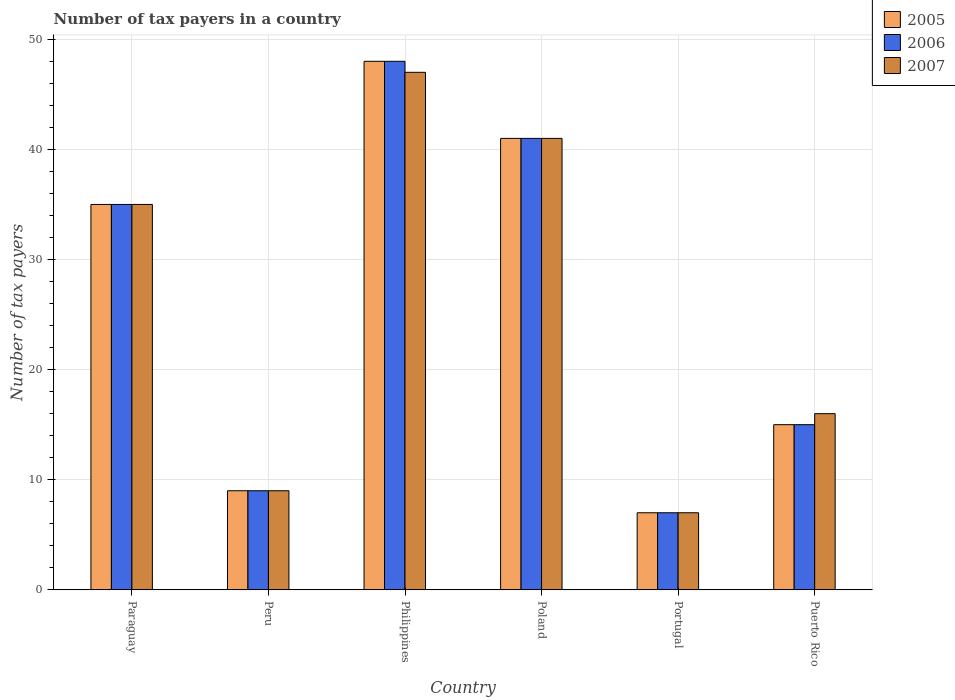How many bars are there on the 3rd tick from the left?
Make the answer very short. 3. What is the label of the 2nd group of bars from the left?
Provide a short and direct response. Peru. In how many cases, is the number of bars for a given country not equal to the number of legend labels?
Provide a short and direct response. 0. Across all countries, what is the minimum number of tax payers in in 2005?
Make the answer very short. 7. In which country was the number of tax payers in in 2006 maximum?
Provide a short and direct response. Philippines. In which country was the number of tax payers in in 2007 minimum?
Keep it short and to the point. Portugal. What is the total number of tax payers in in 2006 in the graph?
Provide a succinct answer. 155. What is the difference between the number of tax payers in in 2005 in Poland and that in Puerto Rico?
Provide a succinct answer. 26. What is the average number of tax payers in in 2005 per country?
Provide a succinct answer. 25.83. In how many countries, is the number of tax payers in in 2007 greater than 6?
Provide a short and direct response. 6. What is the ratio of the number of tax payers in in 2007 in Philippines to that in Puerto Rico?
Give a very brief answer. 2.94. Is the number of tax payers in in 2005 in Philippines less than that in Poland?
Give a very brief answer. No. In how many countries, is the number of tax payers in in 2007 greater than the average number of tax payers in in 2007 taken over all countries?
Your answer should be compact. 3. What does the 3rd bar from the left in Poland represents?
Provide a succinct answer. 2007. Is it the case that in every country, the sum of the number of tax payers in in 2005 and number of tax payers in in 2007 is greater than the number of tax payers in in 2006?
Your response must be concise. Yes. How many bars are there?
Ensure brevity in your answer.  18. How many countries are there in the graph?
Offer a very short reply. 6. What is the difference between two consecutive major ticks on the Y-axis?
Your response must be concise. 10. Where does the legend appear in the graph?
Provide a short and direct response. Top right. How many legend labels are there?
Offer a terse response. 3. What is the title of the graph?
Keep it short and to the point. Number of tax payers in a country. What is the label or title of the X-axis?
Give a very brief answer. Country. What is the label or title of the Y-axis?
Offer a terse response. Number of tax payers. What is the Number of tax payers in 2006 in Peru?
Your answer should be very brief. 9. What is the Number of tax payers of 2005 in Philippines?
Keep it short and to the point. 48. What is the Number of tax payers in 2007 in Philippines?
Offer a terse response. 47. What is the Number of tax payers in 2006 in Poland?
Your response must be concise. 41. What is the Number of tax payers of 2007 in Poland?
Your answer should be compact. 41. What is the Number of tax payers in 2005 in Portugal?
Your response must be concise. 7. What is the Number of tax payers in 2006 in Puerto Rico?
Provide a succinct answer. 15. Across all countries, what is the maximum Number of tax payers in 2007?
Provide a succinct answer. 47. Across all countries, what is the minimum Number of tax payers in 2005?
Offer a terse response. 7. Across all countries, what is the minimum Number of tax payers of 2006?
Provide a succinct answer. 7. Across all countries, what is the minimum Number of tax payers in 2007?
Keep it short and to the point. 7. What is the total Number of tax payers of 2005 in the graph?
Your answer should be compact. 155. What is the total Number of tax payers of 2006 in the graph?
Your answer should be compact. 155. What is the total Number of tax payers in 2007 in the graph?
Your answer should be very brief. 155. What is the difference between the Number of tax payers in 2005 in Paraguay and that in Peru?
Provide a succinct answer. 26. What is the difference between the Number of tax payers of 2006 in Paraguay and that in Peru?
Your response must be concise. 26. What is the difference between the Number of tax payers in 2005 in Paraguay and that in Philippines?
Ensure brevity in your answer.  -13. What is the difference between the Number of tax payers in 2006 in Paraguay and that in Philippines?
Offer a very short reply. -13. What is the difference between the Number of tax payers of 2007 in Paraguay and that in Philippines?
Your answer should be compact. -12. What is the difference between the Number of tax payers in 2005 in Paraguay and that in Poland?
Keep it short and to the point. -6. What is the difference between the Number of tax payers of 2005 in Paraguay and that in Portugal?
Your response must be concise. 28. What is the difference between the Number of tax payers in 2006 in Paraguay and that in Portugal?
Make the answer very short. 28. What is the difference between the Number of tax payers of 2007 in Paraguay and that in Portugal?
Offer a terse response. 28. What is the difference between the Number of tax payers of 2005 in Peru and that in Philippines?
Your response must be concise. -39. What is the difference between the Number of tax payers in 2006 in Peru and that in Philippines?
Provide a succinct answer. -39. What is the difference between the Number of tax payers of 2007 in Peru and that in Philippines?
Provide a short and direct response. -38. What is the difference between the Number of tax payers in 2005 in Peru and that in Poland?
Provide a succinct answer. -32. What is the difference between the Number of tax payers in 2006 in Peru and that in Poland?
Your answer should be very brief. -32. What is the difference between the Number of tax payers in 2007 in Peru and that in Poland?
Give a very brief answer. -32. What is the difference between the Number of tax payers of 2005 in Peru and that in Puerto Rico?
Your answer should be compact. -6. What is the difference between the Number of tax payers of 2005 in Philippines and that in Poland?
Provide a short and direct response. 7. What is the difference between the Number of tax payers in 2005 in Philippines and that in Portugal?
Your response must be concise. 41. What is the difference between the Number of tax payers of 2007 in Philippines and that in Portugal?
Your response must be concise. 40. What is the difference between the Number of tax payers in 2006 in Philippines and that in Puerto Rico?
Keep it short and to the point. 33. What is the difference between the Number of tax payers in 2007 in Philippines and that in Puerto Rico?
Your answer should be very brief. 31. What is the difference between the Number of tax payers in 2007 in Poland and that in Portugal?
Provide a succinct answer. 34. What is the difference between the Number of tax payers of 2006 in Poland and that in Puerto Rico?
Keep it short and to the point. 26. What is the difference between the Number of tax payers in 2007 in Poland and that in Puerto Rico?
Give a very brief answer. 25. What is the difference between the Number of tax payers in 2006 in Portugal and that in Puerto Rico?
Make the answer very short. -8. What is the difference between the Number of tax payers of 2007 in Portugal and that in Puerto Rico?
Give a very brief answer. -9. What is the difference between the Number of tax payers of 2005 in Paraguay and the Number of tax payers of 2006 in Peru?
Offer a terse response. 26. What is the difference between the Number of tax payers in 2006 in Paraguay and the Number of tax payers in 2007 in Peru?
Provide a succinct answer. 26. What is the difference between the Number of tax payers of 2005 in Paraguay and the Number of tax payers of 2007 in Philippines?
Your answer should be very brief. -12. What is the difference between the Number of tax payers in 2006 in Paraguay and the Number of tax payers in 2007 in Philippines?
Give a very brief answer. -12. What is the difference between the Number of tax payers in 2005 in Paraguay and the Number of tax payers in 2006 in Poland?
Keep it short and to the point. -6. What is the difference between the Number of tax payers in 2005 in Paraguay and the Number of tax payers in 2007 in Poland?
Keep it short and to the point. -6. What is the difference between the Number of tax payers of 2006 in Paraguay and the Number of tax payers of 2007 in Poland?
Make the answer very short. -6. What is the difference between the Number of tax payers in 2005 in Peru and the Number of tax payers in 2006 in Philippines?
Your response must be concise. -39. What is the difference between the Number of tax payers in 2005 in Peru and the Number of tax payers in 2007 in Philippines?
Your answer should be very brief. -38. What is the difference between the Number of tax payers of 2006 in Peru and the Number of tax payers of 2007 in Philippines?
Your answer should be very brief. -38. What is the difference between the Number of tax payers in 2005 in Peru and the Number of tax payers in 2006 in Poland?
Keep it short and to the point. -32. What is the difference between the Number of tax payers of 2005 in Peru and the Number of tax payers of 2007 in Poland?
Offer a very short reply. -32. What is the difference between the Number of tax payers in 2006 in Peru and the Number of tax payers in 2007 in Poland?
Keep it short and to the point. -32. What is the difference between the Number of tax payers in 2005 in Peru and the Number of tax payers in 2006 in Portugal?
Your answer should be compact. 2. What is the difference between the Number of tax payers of 2005 in Peru and the Number of tax payers of 2007 in Portugal?
Offer a terse response. 2. What is the difference between the Number of tax payers in 2005 in Philippines and the Number of tax payers in 2006 in Poland?
Provide a short and direct response. 7. What is the difference between the Number of tax payers of 2006 in Philippines and the Number of tax payers of 2007 in Poland?
Provide a short and direct response. 7. What is the difference between the Number of tax payers in 2006 in Philippines and the Number of tax payers in 2007 in Portugal?
Your answer should be compact. 41. What is the difference between the Number of tax payers in 2005 in Philippines and the Number of tax payers in 2007 in Puerto Rico?
Provide a succinct answer. 32. What is the difference between the Number of tax payers in 2005 in Poland and the Number of tax payers in 2006 in Puerto Rico?
Ensure brevity in your answer.  26. What is the difference between the Number of tax payers in 2005 in Poland and the Number of tax payers in 2007 in Puerto Rico?
Provide a succinct answer. 25. What is the difference between the Number of tax payers of 2005 in Portugal and the Number of tax payers of 2006 in Puerto Rico?
Provide a succinct answer. -8. What is the difference between the Number of tax payers of 2005 in Portugal and the Number of tax payers of 2007 in Puerto Rico?
Make the answer very short. -9. What is the difference between the Number of tax payers of 2006 in Portugal and the Number of tax payers of 2007 in Puerto Rico?
Your answer should be very brief. -9. What is the average Number of tax payers of 2005 per country?
Give a very brief answer. 25.83. What is the average Number of tax payers in 2006 per country?
Offer a terse response. 25.83. What is the average Number of tax payers of 2007 per country?
Your response must be concise. 25.83. What is the difference between the Number of tax payers in 2005 and Number of tax payers in 2007 in Paraguay?
Ensure brevity in your answer.  0. What is the difference between the Number of tax payers of 2006 and Number of tax payers of 2007 in Paraguay?
Provide a short and direct response. 0. What is the difference between the Number of tax payers in 2005 and Number of tax payers in 2006 in Peru?
Provide a short and direct response. 0. What is the difference between the Number of tax payers in 2006 and Number of tax payers in 2007 in Peru?
Your answer should be compact. 0. What is the difference between the Number of tax payers in 2005 and Number of tax payers in 2007 in Poland?
Make the answer very short. 0. What is the difference between the Number of tax payers in 2006 and Number of tax payers in 2007 in Poland?
Ensure brevity in your answer.  0. What is the difference between the Number of tax payers of 2005 and Number of tax payers of 2007 in Portugal?
Your answer should be very brief. 0. What is the difference between the Number of tax payers in 2006 and Number of tax payers in 2007 in Portugal?
Keep it short and to the point. 0. What is the difference between the Number of tax payers in 2005 and Number of tax payers in 2006 in Puerto Rico?
Provide a short and direct response. 0. What is the difference between the Number of tax payers of 2005 and Number of tax payers of 2007 in Puerto Rico?
Your answer should be compact. -1. What is the difference between the Number of tax payers of 2006 and Number of tax payers of 2007 in Puerto Rico?
Provide a succinct answer. -1. What is the ratio of the Number of tax payers of 2005 in Paraguay to that in Peru?
Your response must be concise. 3.89. What is the ratio of the Number of tax payers of 2006 in Paraguay to that in Peru?
Your answer should be very brief. 3.89. What is the ratio of the Number of tax payers of 2007 in Paraguay to that in Peru?
Offer a terse response. 3.89. What is the ratio of the Number of tax payers in 2005 in Paraguay to that in Philippines?
Offer a terse response. 0.73. What is the ratio of the Number of tax payers in 2006 in Paraguay to that in Philippines?
Your answer should be very brief. 0.73. What is the ratio of the Number of tax payers in 2007 in Paraguay to that in Philippines?
Make the answer very short. 0.74. What is the ratio of the Number of tax payers of 2005 in Paraguay to that in Poland?
Ensure brevity in your answer.  0.85. What is the ratio of the Number of tax payers of 2006 in Paraguay to that in Poland?
Provide a short and direct response. 0.85. What is the ratio of the Number of tax payers in 2007 in Paraguay to that in Poland?
Provide a succinct answer. 0.85. What is the ratio of the Number of tax payers in 2005 in Paraguay to that in Portugal?
Keep it short and to the point. 5. What is the ratio of the Number of tax payers of 2006 in Paraguay to that in Portugal?
Your answer should be very brief. 5. What is the ratio of the Number of tax payers of 2005 in Paraguay to that in Puerto Rico?
Keep it short and to the point. 2.33. What is the ratio of the Number of tax payers in 2006 in Paraguay to that in Puerto Rico?
Your answer should be very brief. 2.33. What is the ratio of the Number of tax payers in 2007 in Paraguay to that in Puerto Rico?
Your answer should be very brief. 2.19. What is the ratio of the Number of tax payers of 2005 in Peru to that in Philippines?
Keep it short and to the point. 0.19. What is the ratio of the Number of tax payers in 2006 in Peru to that in Philippines?
Provide a succinct answer. 0.19. What is the ratio of the Number of tax payers in 2007 in Peru to that in Philippines?
Your answer should be compact. 0.19. What is the ratio of the Number of tax payers in 2005 in Peru to that in Poland?
Ensure brevity in your answer.  0.22. What is the ratio of the Number of tax payers in 2006 in Peru to that in Poland?
Give a very brief answer. 0.22. What is the ratio of the Number of tax payers of 2007 in Peru to that in Poland?
Your answer should be very brief. 0.22. What is the ratio of the Number of tax payers of 2006 in Peru to that in Portugal?
Provide a succinct answer. 1.29. What is the ratio of the Number of tax payers in 2007 in Peru to that in Portugal?
Make the answer very short. 1.29. What is the ratio of the Number of tax payers of 2006 in Peru to that in Puerto Rico?
Your response must be concise. 0.6. What is the ratio of the Number of tax payers of 2007 in Peru to that in Puerto Rico?
Ensure brevity in your answer.  0.56. What is the ratio of the Number of tax payers in 2005 in Philippines to that in Poland?
Your answer should be very brief. 1.17. What is the ratio of the Number of tax payers in 2006 in Philippines to that in Poland?
Offer a terse response. 1.17. What is the ratio of the Number of tax payers of 2007 in Philippines to that in Poland?
Offer a very short reply. 1.15. What is the ratio of the Number of tax payers in 2005 in Philippines to that in Portugal?
Your answer should be very brief. 6.86. What is the ratio of the Number of tax payers of 2006 in Philippines to that in Portugal?
Your response must be concise. 6.86. What is the ratio of the Number of tax payers of 2007 in Philippines to that in Portugal?
Your answer should be very brief. 6.71. What is the ratio of the Number of tax payers of 2005 in Philippines to that in Puerto Rico?
Make the answer very short. 3.2. What is the ratio of the Number of tax payers in 2007 in Philippines to that in Puerto Rico?
Give a very brief answer. 2.94. What is the ratio of the Number of tax payers of 2005 in Poland to that in Portugal?
Offer a terse response. 5.86. What is the ratio of the Number of tax payers of 2006 in Poland to that in Portugal?
Give a very brief answer. 5.86. What is the ratio of the Number of tax payers of 2007 in Poland to that in Portugal?
Ensure brevity in your answer.  5.86. What is the ratio of the Number of tax payers of 2005 in Poland to that in Puerto Rico?
Provide a succinct answer. 2.73. What is the ratio of the Number of tax payers of 2006 in Poland to that in Puerto Rico?
Make the answer very short. 2.73. What is the ratio of the Number of tax payers of 2007 in Poland to that in Puerto Rico?
Your answer should be very brief. 2.56. What is the ratio of the Number of tax payers in 2005 in Portugal to that in Puerto Rico?
Make the answer very short. 0.47. What is the ratio of the Number of tax payers in 2006 in Portugal to that in Puerto Rico?
Provide a succinct answer. 0.47. What is the ratio of the Number of tax payers in 2007 in Portugal to that in Puerto Rico?
Provide a succinct answer. 0.44. What is the difference between the highest and the second highest Number of tax payers of 2006?
Keep it short and to the point. 7. What is the difference between the highest and the second highest Number of tax payers of 2007?
Offer a terse response. 6. What is the difference between the highest and the lowest Number of tax payers of 2006?
Provide a short and direct response. 41. What is the difference between the highest and the lowest Number of tax payers in 2007?
Make the answer very short. 40. 